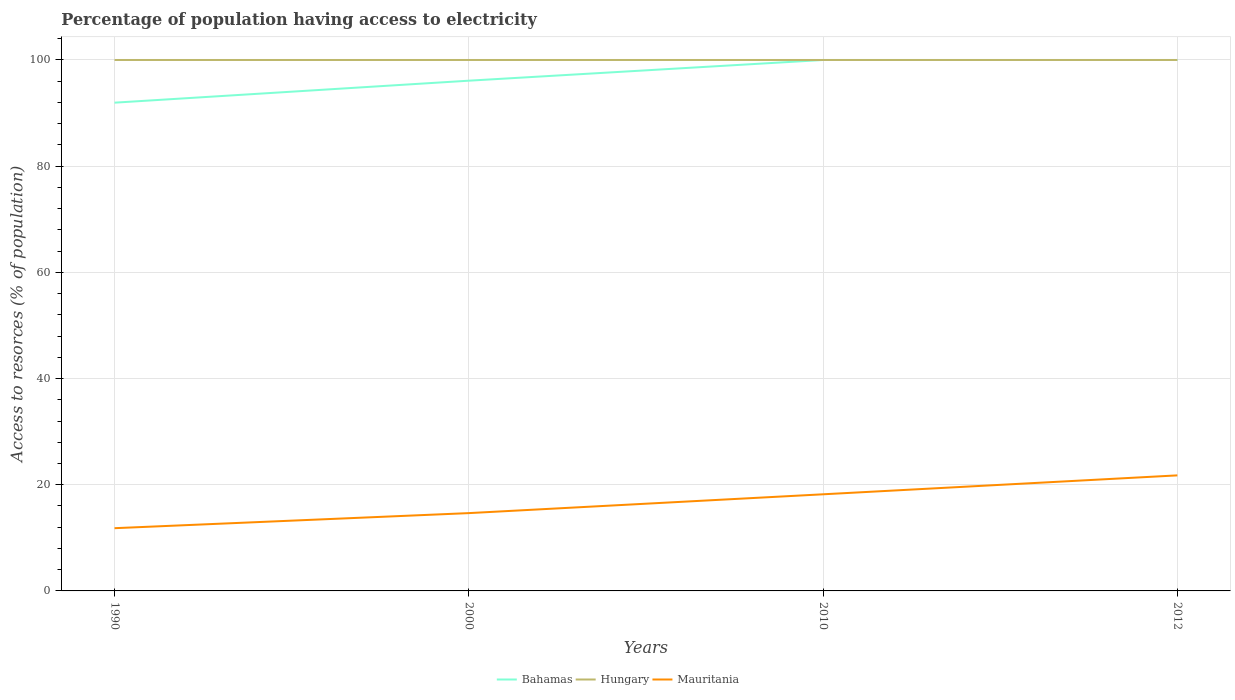How many different coloured lines are there?
Provide a succinct answer. 3. Across all years, what is the maximum percentage of population having access to electricity in Hungary?
Offer a terse response. 100. What is the total percentage of population having access to electricity in Bahamas in the graph?
Your answer should be compact. -4.14. What is the difference between the highest and the second highest percentage of population having access to electricity in Mauritania?
Your answer should be compact. 9.95. What is the difference between two consecutive major ticks on the Y-axis?
Keep it short and to the point. 20. How many legend labels are there?
Give a very brief answer. 3. How are the legend labels stacked?
Provide a short and direct response. Horizontal. What is the title of the graph?
Give a very brief answer. Percentage of population having access to electricity. What is the label or title of the Y-axis?
Provide a short and direct response. Access to resorces (% of population). What is the Access to resorces (% of population) in Bahamas in 1990?
Your response must be concise. 91.96. What is the Access to resorces (% of population) of Mauritania in 1990?
Offer a very short reply. 11.82. What is the Access to resorces (% of population) of Bahamas in 2000?
Provide a short and direct response. 96.1. What is the Access to resorces (% of population) of Mauritania in 2000?
Provide a short and direct response. 14.66. What is the Access to resorces (% of population) of Bahamas in 2010?
Provide a succinct answer. 100. What is the Access to resorces (% of population) of Hungary in 2010?
Offer a terse response. 100. What is the Access to resorces (% of population) in Bahamas in 2012?
Your response must be concise. 100. What is the Access to resorces (% of population) of Mauritania in 2012?
Give a very brief answer. 21.76. Across all years, what is the maximum Access to resorces (% of population) of Bahamas?
Offer a very short reply. 100. Across all years, what is the maximum Access to resorces (% of population) in Mauritania?
Provide a succinct answer. 21.76. Across all years, what is the minimum Access to resorces (% of population) in Bahamas?
Provide a succinct answer. 91.96. Across all years, what is the minimum Access to resorces (% of population) in Mauritania?
Give a very brief answer. 11.82. What is the total Access to resorces (% of population) in Bahamas in the graph?
Keep it short and to the point. 388.06. What is the total Access to resorces (% of population) of Mauritania in the graph?
Your answer should be very brief. 66.43. What is the difference between the Access to resorces (% of population) in Bahamas in 1990 and that in 2000?
Your answer should be compact. -4.14. What is the difference between the Access to resorces (% of population) of Hungary in 1990 and that in 2000?
Provide a succinct answer. 0. What is the difference between the Access to resorces (% of population) in Mauritania in 1990 and that in 2000?
Your response must be concise. -2.84. What is the difference between the Access to resorces (% of population) in Bahamas in 1990 and that in 2010?
Offer a very short reply. -8.04. What is the difference between the Access to resorces (% of population) of Mauritania in 1990 and that in 2010?
Offer a terse response. -6.38. What is the difference between the Access to resorces (% of population) of Bahamas in 1990 and that in 2012?
Ensure brevity in your answer.  -8.04. What is the difference between the Access to resorces (% of population) of Hungary in 1990 and that in 2012?
Make the answer very short. 0. What is the difference between the Access to resorces (% of population) of Mauritania in 1990 and that in 2012?
Provide a short and direct response. -9.95. What is the difference between the Access to resorces (% of population) of Mauritania in 2000 and that in 2010?
Offer a terse response. -3.54. What is the difference between the Access to resorces (% of population) in Hungary in 2000 and that in 2012?
Make the answer very short. 0. What is the difference between the Access to resorces (% of population) of Mauritania in 2000 and that in 2012?
Your response must be concise. -7.11. What is the difference between the Access to resorces (% of population) of Mauritania in 2010 and that in 2012?
Provide a succinct answer. -3.56. What is the difference between the Access to resorces (% of population) in Bahamas in 1990 and the Access to resorces (% of population) in Hungary in 2000?
Keep it short and to the point. -8.04. What is the difference between the Access to resorces (% of population) of Bahamas in 1990 and the Access to resorces (% of population) of Mauritania in 2000?
Provide a short and direct response. 77.31. What is the difference between the Access to resorces (% of population) of Hungary in 1990 and the Access to resorces (% of population) of Mauritania in 2000?
Provide a short and direct response. 85.34. What is the difference between the Access to resorces (% of population) in Bahamas in 1990 and the Access to resorces (% of population) in Hungary in 2010?
Provide a short and direct response. -8.04. What is the difference between the Access to resorces (% of population) of Bahamas in 1990 and the Access to resorces (% of population) of Mauritania in 2010?
Offer a terse response. 73.76. What is the difference between the Access to resorces (% of population) in Hungary in 1990 and the Access to resorces (% of population) in Mauritania in 2010?
Keep it short and to the point. 81.8. What is the difference between the Access to resorces (% of population) of Bahamas in 1990 and the Access to resorces (% of population) of Hungary in 2012?
Your answer should be very brief. -8.04. What is the difference between the Access to resorces (% of population) of Bahamas in 1990 and the Access to resorces (% of population) of Mauritania in 2012?
Provide a short and direct response. 70.2. What is the difference between the Access to resorces (% of population) in Hungary in 1990 and the Access to resorces (% of population) in Mauritania in 2012?
Give a very brief answer. 78.24. What is the difference between the Access to resorces (% of population) in Bahamas in 2000 and the Access to resorces (% of population) in Hungary in 2010?
Make the answer very short. -3.9. What is the difference between the Access to resorces (% of population) of Bahamas in 2000 and the Access to resorces (% of population) of Mauritania in 2010?
Provide a succinct answer. 77.9. What is the difference between the Access to resorces (% of population) of Hungary in 2000 and the Access to resorces (% of population) of Mauritania in 2010?
Provide a short and direct response. 81.8. What is the difference between the Access to resorces (% of population) of Bahamas in 2000 and the Access to resorces (% of population) of Mauritania in 2012?
Provide a succinct answer. 74.34. What is the difference between the Access to resorces (% of population) in Hungary in 2000 and the Access to resorces (% of population) in Mauritania in 2012?
Make the answer very short. 78.24. What is the difference between the Access to resorces (% of population) in Bahamas in 2010 and the Access to resorces (% of population) in Hungary in 2012?
Your answer should be very brief. 0. What is the difference between the Access to resorces (% of population) in Bahamas in 2010 and the Access to resorces (% of population) in Mauritania in 2012?
Your answer should be very brief. 78.24. What is the difference between the Access to resorces (% of population) of Hungary in 2010 and the Access to resorces (% of population) of Mauritania in 2012?
Provide a succinct answer. 78.24. What is the average Access to resorces (% of population) in Bahamas per year?
Offer a very short reply. 97.02. What is the average Access to resorces (% of population) of Mauritania per year?
Your response must be concise. 16.61. In the year 1990, what is the difference between the Access to resorces (% of population) of Bahamas and Access to resorces (% of population) of Hungary?
Provide a succinct answer. -8.04. In the year 1990, what is the difference between the Access to resorces (% of population) in Bahamas and Access to resorces (% of population) in Mauritania?
Your response must be concise. 80.15. In the year 1990, what is the difference between the Access to resorces (% of population) in Hungary and Access to resorces (% of population) in Mauritania?
Provide a succinct answer. 88.18. In the year 2000, what is the difference between the Access to resorces (% of population) of Bahamas and Access to resorces (% of population) of Hungary?
Give a very brief answer. -3.9. In the year 2000, what is the difference between the Access to resorces (% of population) in Bahamas and Access to resorces (% of population) in Mauritania?
Your answer should be compact. 81.44. In the year 2000, what is the difference between the Access to resorces (% of population) of Hungary and Access to resorces (% of population) of Mauritania?
Provide a succinct answer. 85.34. In the year 2010, what is the difference between the Access to resorces (% of population) in Bahamas and Access to resorces (% of population) in Mauritania?
Offer a very short reply. 81.8. In the year 2010, what is the difference between the Access to resorces (% of population) of Hungary and Access to resorces (% of population) of Mauritania?
Ensure brevity in your answer.  81.8. In the year 2012, what is the difference between the Access to resorces (% of population) of Bahamas and Access to resorces (% of population) of Hungary?
Give a very brief answer. 0. In the year 2012, what is the difference between the Access to resorces (% of population) of Bahamas and Access to resorces (% of population) of Mauritania?
Keep it short and to the point. 78.24. In the year 2012, what is the difference between the Access to resorces (% of population) in Hungary and Access to resorces (% of population) in Mauritania?
Give a very brief answer. 78.24. What is the ratio of the Access to resorces (% of population) of Bahamas in 1990 to that in 2000?
Your answer should be very brief. 0.96. What is the ratio of the Access to resorces (% of population) in Mauritania in 1990 to that in 2000?
Give a very brief answer. 0.81. What is the ratio of the Access to resorces (% of population) in Bahamas in 1990 to that in 2010?
Your response must be concise. 0.92. What is the ratio of the Access to resorces (% of population) in Hungary in 1990 to that in 2010?
Ensure brevity in your answer.  1. What is the ratio of the Access to resorces (% of population) of Mauritania in 1990 to that in 2010?
Make the answer very short. 0.65. What is the ratio of the Access to resorces (% of population) of Bahamas in 1990 to that in 2012?
Your response must be concise. 0.92. What is the ratio of the Access to resorces (% of population) of Mauritania in 1990 to that in 2012?
Your answer should be very brief. 0.54. What is the ratio of the Access to resorces (% of population) of Bahamas in 2000 to that in 2010?
Give a very brief answer. 0.96. What is the ratio of the Access to resorces (% of population) of Mauritania in 2000 to that in 2010?
Provide a succinct answer. 0.81. What is the ratio of the Access to resorces (% of population) in Hungary in 2000 to that in 2012?
Provide a succinct answer. 1. What is the ratio of the Access to resorces (% of population) of Mauritania in 2000 to that in 2012?
Offer a terse response. 0.67. What is the ratio of the Access to resorces (% of population) of Bahamas in 2010 to that in 2012?
Ensure brevity in your answer.  1. What is the ratio of the Access to resorces (% of population) in Hungary in 2010 to that in 2012?
Make the answer very short. 1. What is the ratio of the Access to resorces (% of population) of Mauritania in 2010 to that in 2012?
Your answer should be compact. 0.84. What is the difference between the highest and the second highest Access to resorces (% of population) in Bahamas?
Your response must be concise. 0. What is the difference between the highest and the second highest Access to resorces (% of population) of Hungary?
Give a very brief answer. 0. What is the difference between the highest and the second highest Access to resorces (% of population) in Mauritania?
Give a very brief answer. 3.56. What is the difference between the highest and the lowest Access to resorces (% of population) of Bahamas?
Ensure brevity in your answer.  8.04. What is the difference between the highest and the lowest Access to resorces (% of population) in Hungary?
Provide a short and direct response. 0. What is the difference between the highest and the lowest Access to resorces (% of population) in Mauritania?
Your answer should be compact. 9.95. 